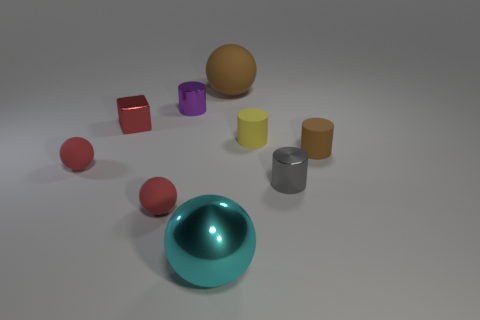Are there any other things that have the same shape as the red shiny thing?
Your answer should be very brief. No. There is a brown thing to the left of the shiny thing that is to the right of the object that is behind the purple cylinder; what is its size?
Provide a succinct answer. Large. There is a gray cylinder that is the same size as the purple metal thing; what material is it?
Your answer should be very brief. Metal. Is there a purple metallic cylinder that has the same size as the gray cylinder?
Your answer should be very brief. Yes. Is the shape of the large brown thing the same as the large cyan object?
Provide a short and direct response. Yes. Are there any large balls to the left of the small metal thing in front of the brown thing to the right of the brown ball?
Make the answer very short. Yes. How many other things are the same color as the big matte sphere?
Your answer should be compact. 1. There is a matte sphere that is right of the cyan sphere; does it have the same size as the rubber cylinder that is left of the brown cylinder?
Ensure brevity in your answer.  No. Are there an equal number of gray cylinders that are behind the tiny shiny cube and big brown matte objects on the right side of the small yellow cylinder?
Your answer should be very brief. Yes. Does the red block have the same size as the rubber sphere that is on the left side of the shiny cube?
Offer a terse response. Yes. 